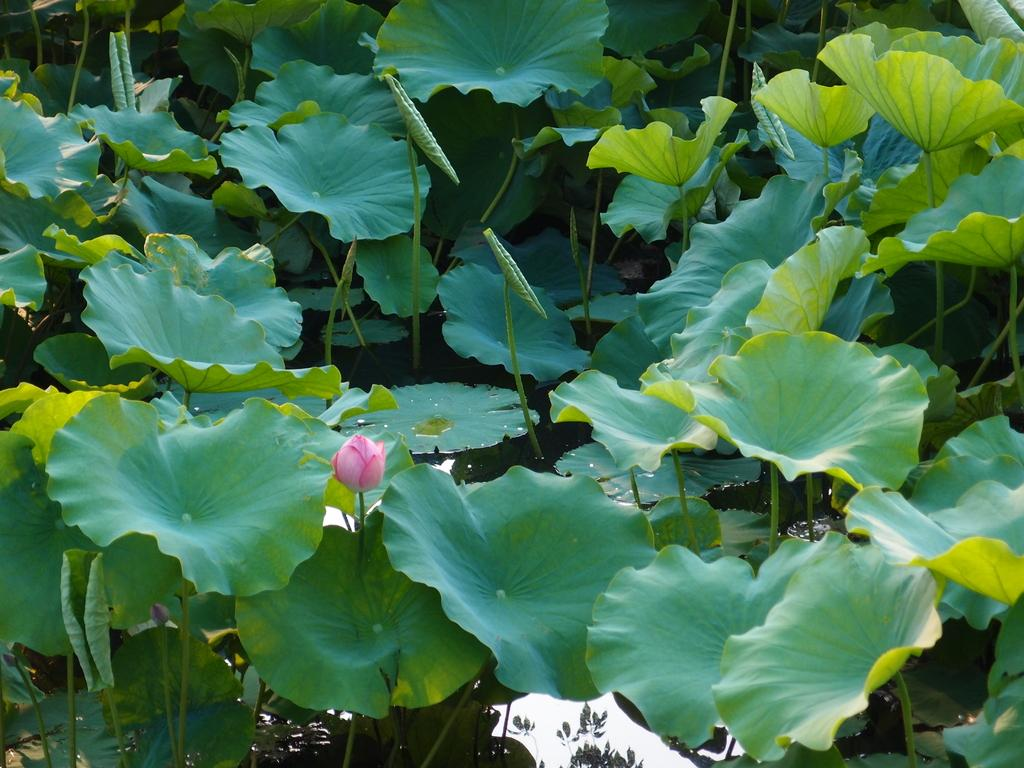What type of vegetation is present in the image? There are many lotus leaves in the image. Where are the lotus leaves located? The lotus leaves are in a pond. Can you describe any other part of the lotus plant in the image? There is a lotus bud in the image. What type of silk can be seen on the way in the image? There is no silk or path visible in the image; it features lotus leaves in a pond and a lotus bud. 